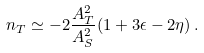Convert formula to latex. <formula><loc_0><loc_0><loc_500><loc_500>n _ { T } \simeq - 2 \frac { A _ { T } ^ { 2 } } { A _ { S } ^ { 2 } } ( 1 + 3 \epsilon - 2 \eta ) \, .</formula> 